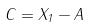<formula> <loc_0><loc_0><loc_500><loc_500>C = X _ { 1 } - A</formula> 